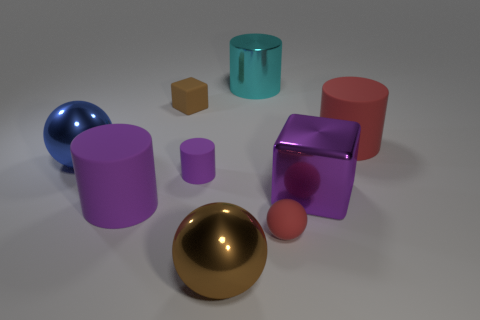How many other objects are there of the same size as the brown ball?
Your response must be concise. 5. Is there any other thing that is the same color as the tiny sphere?
Offer a very short reply. Yes. There is a red rubber object in front of the big blue thing; how big is it?
Your answer should be compact. Small. How big is the red thing that is to the left of the big matte cylinder right of the sphere that is in front of the tiny red ball?
Make the answer very short. Small. The large rubber cylinder that is right of the big metal ball that is in front of the purple block is what color?
Offer a very short reply. Red. What is the material of the other large thing that is the same shape as the blue metallic object?
Offer a very short reply. Metal. Are there any large cyan shiny cylinders behind the big blue thing?
Provide a succinct answer. Yes. What number of large cubes are there?
Provide a short and direct response. 1. There is a large rubber cylinder that is on the right side of the cyan metallic object; how many large brown spheres are right of it?
Make the answer very short. 0. There is a tiny cylinder; is its color the same as the block in front of the rubber cube?
Provide a succinct answer. Yes. 